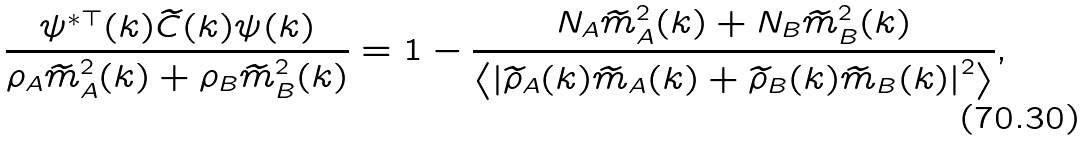<formula> <loc_0><loc_0><loc_500><loc_500>\frac { \psi ^ { * \top } ( k ) \widetilde { C } ( k ) \psi ( k ) } { \rho _ { A } \widetilde { m } _ { A } ^ { 2 } ( k ) + \rho _ { B } \widetilde { m } _ { B } ^ { 2 } ( k ) } = 1 - \frac { N _ { A } \widetilde { m } _ { A } ^ { 2 } ( k ) + N _ { B } \widetilde { m } _ { B } ^ { 2 } ( k ) } { \left < \left | \widetilde { \rho } _ { A } ( k ) \widetilde { m } _ { A } ( k ) + \widetilde { \rho } _ { B } ( k ) \widetilde { m } _ { B } ( k ) \right | ^ { 2 } \right > } ,</formula> 